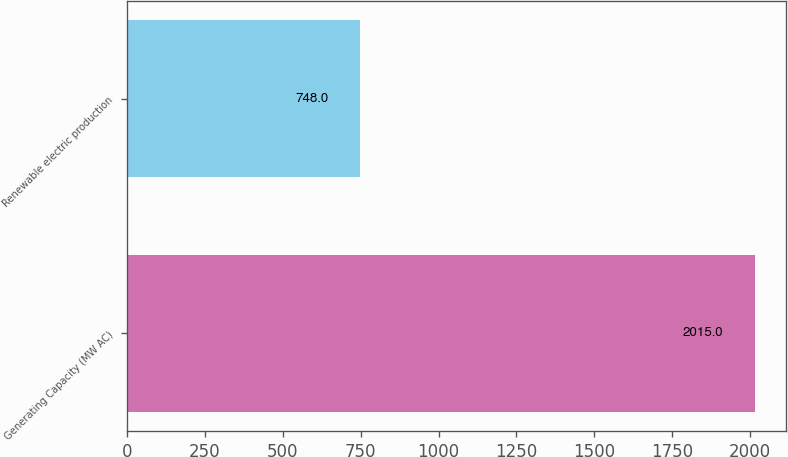<chart> <loc_0><loc_0><loc_500><loc_500><bar_chart><fcel>Generating Capacity (MW AC)<fcel>Renewable electric production<nl><fcel>2015<fcel>748<nl></chart> 